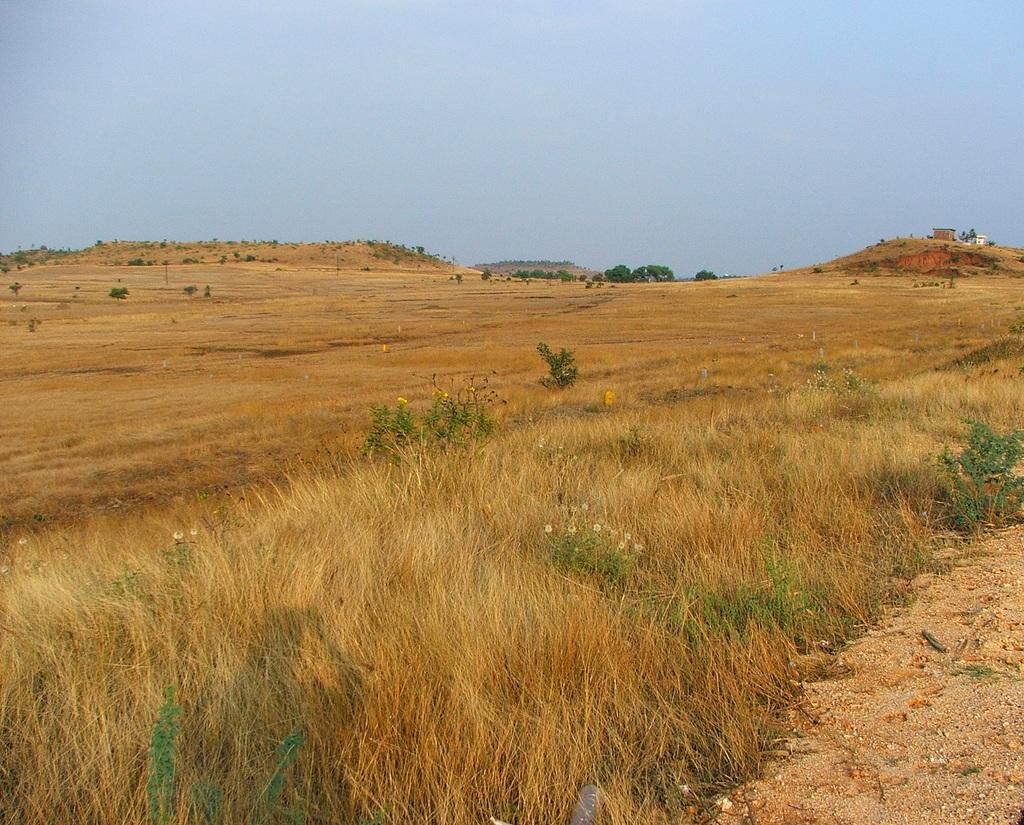What type of vegetation can be seen in the image? There is grass in the image. What other natural elements are present in the image? There are trees in the image. What type of structure is visible in the image? There is a house in the image. What can be seen in the distance in the image? There are mountains visible in the background of the image. How many guitars are being played by the trees in the image? There are no guitars present in the image, as it features grass, trees, a house, and mountains. 